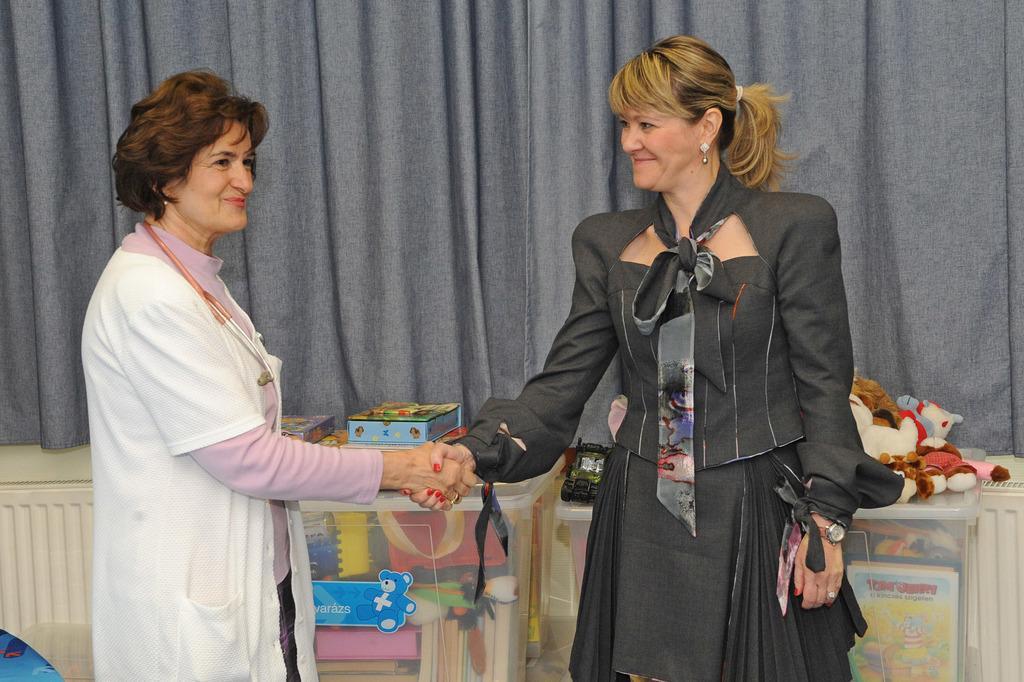Please provide a concise description of this image. In the picture we can see two women are shaking hands and smiling and behind them, we can see a desk with some things and toys are placed on it and behind it we can see the curtain. 